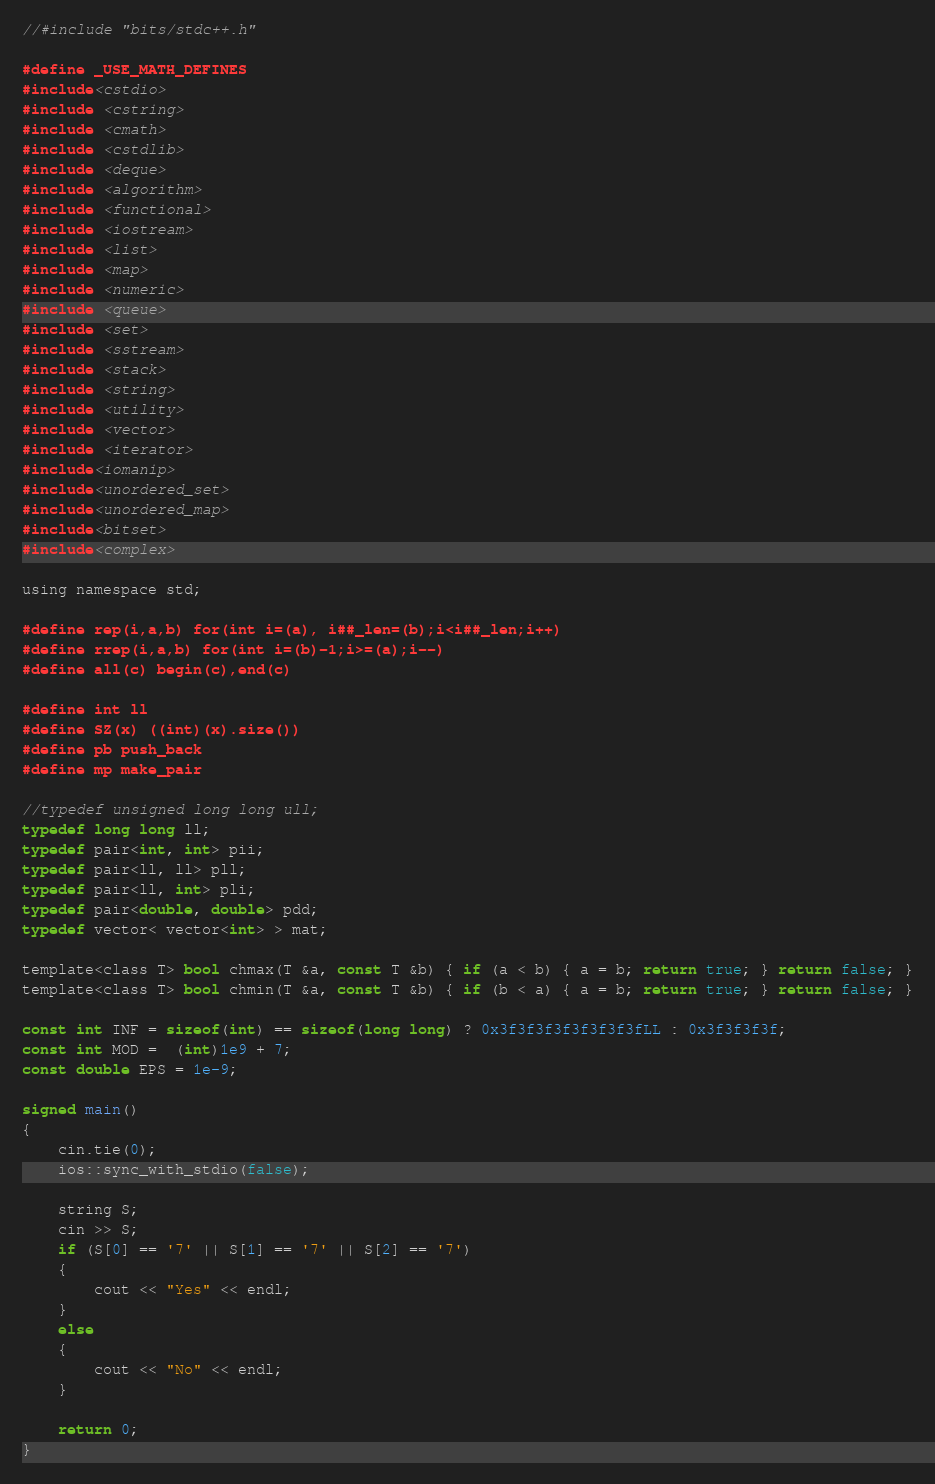<code> <loc_0><loc_0><loc_500><loc_500><_C_>//#include "bits/stdc++.h"

#define _USE_MATH_DEFINES
#include<cstdio>
#include <cstring>
#include <cmath>
#include <cstdlib>
#include <deque>
#include <algorithm>
#include <functional>
#include <iostream>
#include <list>
#include <map>
#include <numeric>
#include <queue>
#include <set>
#include <sstream>
#include <stack>
#include <string>
#include <utility>
#include <vector>
#include <iterator>
#include<iomanip>
#include<unordered_set>
#include<unordered_map>
#include<bitset>
#include<complex>

using namespace std;

#define rep(i,a,b) for(int i=(a), i##_len=(b);i<i##_len;i++)
#define rrep(i,a,b) for(int i=(b)-1;i>=(a);i--)
#define all(c) begin(c),end(c)

#define int ll
#define SZ(x) ((int)(x).size())
#define pb push_back
#define mp make_pair

//typedef unsigned long long ull;
typedef long long ll;
typedef pair<int, int> pii;
typedef pair<ll, ll> pll;
typedef pair<ll, int> pli;
typedef pair<double, double> pdd;
typedef vector< vector<int> > mat;

template<class T> bool chmax(T &a, const T &b) { if (a < b) { a = b; return true; } return false; }
template<class T> bool chmin(T &a, const T &b) { if (b < a) { a = b; return true; } return false; }

const int INF = sizeof(int) == sizeof(long long) ? 0x3f3f3f3f3f3f3f3fLL : 0x3f3f3f3f;
const int MOD =  (int)1e9 + 7;
const double EPS = 1e-9;

signed main()
{
	cin.tie(0);
	ios::sync_with_stdio(false);

	string S;
	cin >> S;
	if (S[0] == '7' || S[1] == '7' || S[2] == '7')
	{
		cout << "Yes" << endl;
	}
	else
	{
		cout << "No" << endl;
	}

	return 0;
}</code> 